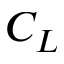Convert formula to latex. <formula><loc_0><loc_0><loc_500><loc_500>C _ { L }</formula> 